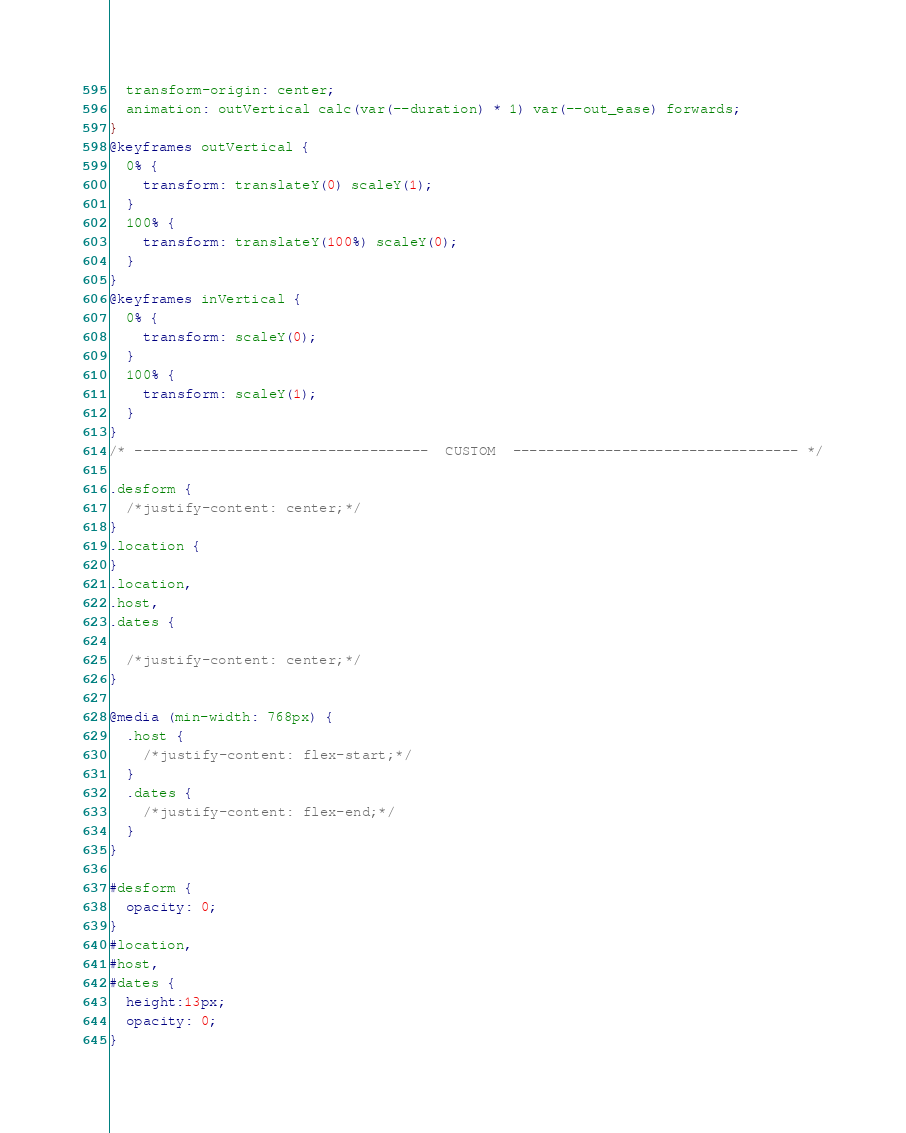Convert code to text. <code><loc_0><loc_0><loc_500><loc_500><_CSS_>  transform-origin: center;
  animation: outVertical calc(var(--duration) * 1) var(--out_ease) forwards;
}
@keyframes outVertical {
  0% {
    transform: translateY(0) scaleY(1);
  }
  100% {
    transform: translateY(100%) scaleY(0);
  }
}
@keyframes inVertical {
  0% {
    transform: scaleY(0);
  }
  100% {
    transform: scaleY(1);
  }
}
/* -----------------------------------  CUSTOM  ---------------------------------- */

.desform {
  /*justify-content: center;*/
}
.location {
}
.location,
.host,
.dates {

  /*justify-content: center;*/
}

@media (min-width: 768px) {
  .host {
    /*justify-content: flex-start;*/
  }
  .dates {
    /*justify-content: flex-end;*/
  }
}

#desform {
  opacity: 0;
}
#location,
#host,
#dates {
  height:13px;
  opacity: 0;
}
</code> 